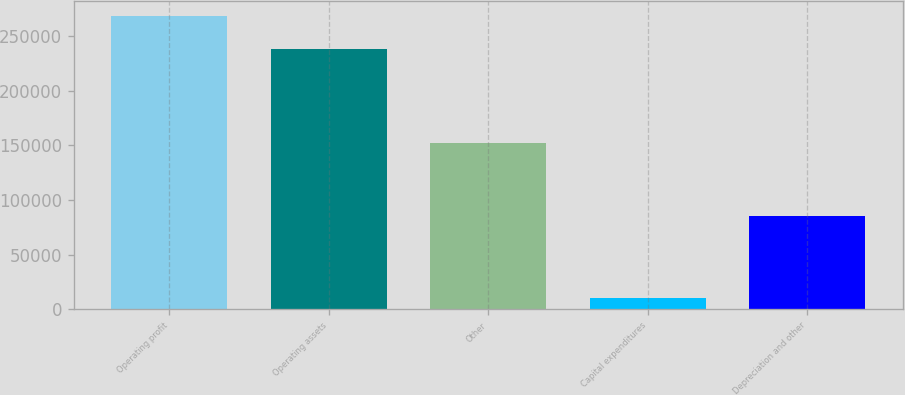<chart> <loc_0><loc_0><loc_500><loc_500><bar_chart><fcel>Operating profit<fcel>Operating assets<fcel>Other<fcel>Capital expenditures<fcel>Depreciation and other<nl><fcel>268172<fcel>237681<fcel>152211<fcel>10231<fcel>85177<nl></chart> 